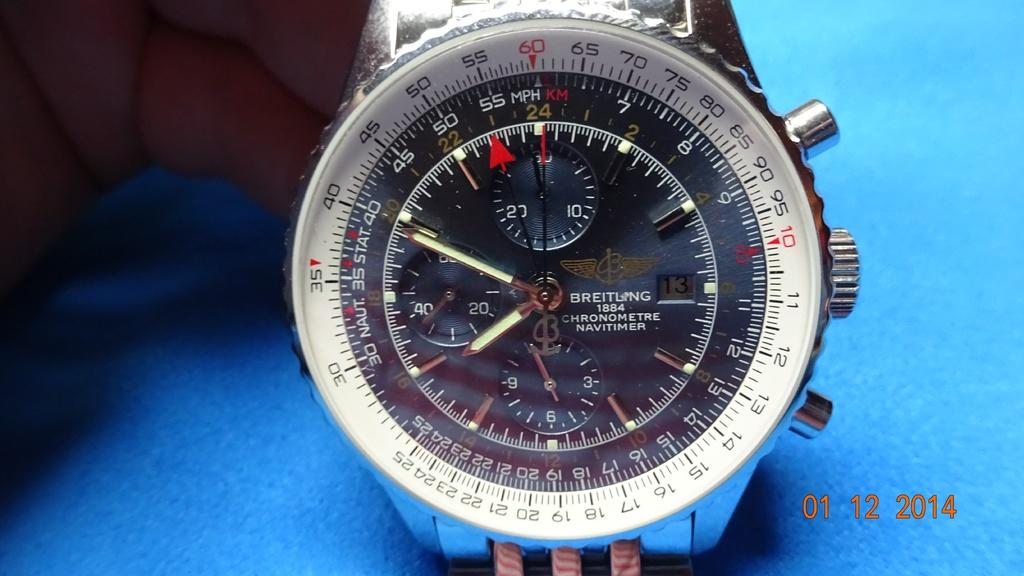<image>
Describe the image concisely. A photo of a watch and compass combo taken on January first of 2014. 